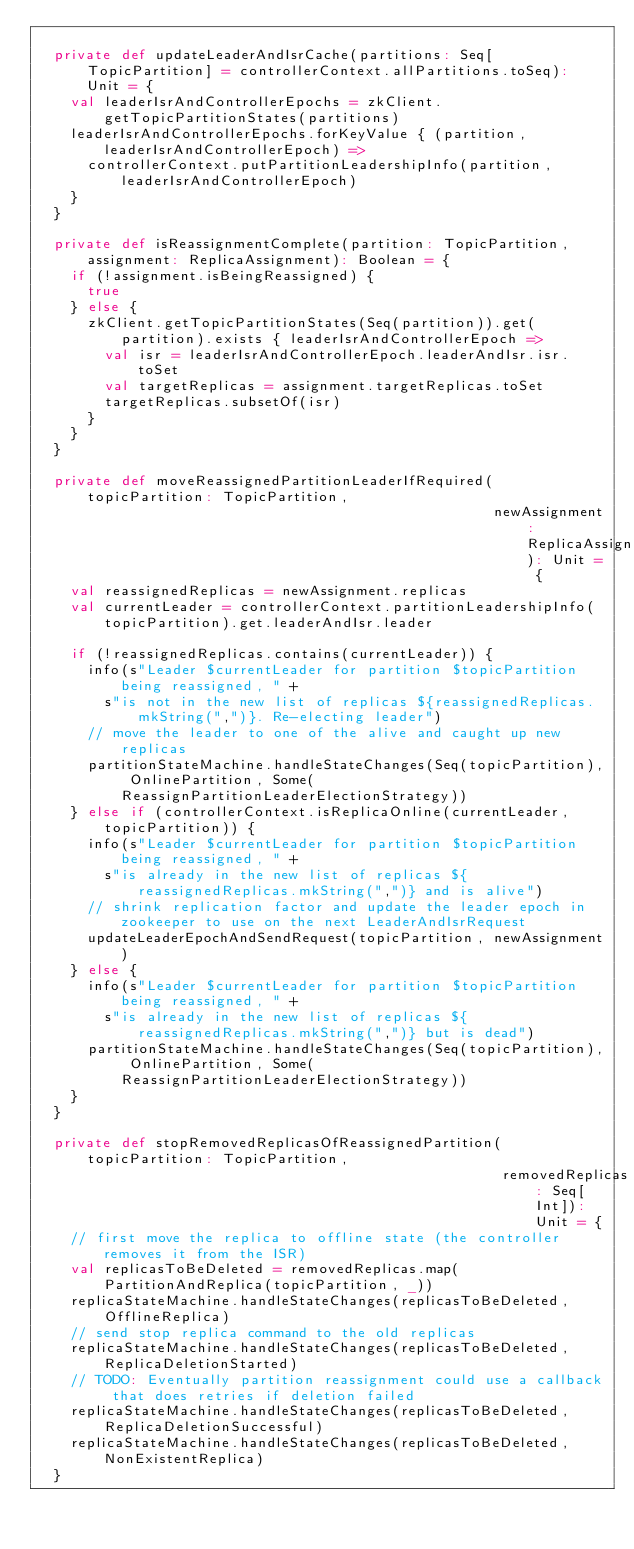Convert code to text. <code><loc_0><loc_0><loc_500><loc_500><_Scala_>
  private def updateLeaderAndIsrCache(partitions: Seq[TopicPartition] = controllerContext.allPartitions.toSeq): Unit = {
    val leaderIsrAndControllerEpochs = zkClient.getTopicPartitionStates(partitions)
    leaderIsrAndControllerEpochs.forKeyValue { (partition, leaderIsrAndControllerEpoch) =>
      controllerContext.putPartitionLeadershipInfo(partition, leaderIsrAndControllerEpoch)
    }
  }

  private def isReassignmentComplete(partition: TopicPartition, assignment: ReplicaAssignment): Boolean = {
    if (!assignment.isBeingReassigned) {
      true
    } else {
      zkClient.getTopicPartitionStates(Seq(partition)).get(partition).exists { leaderIsrAndControllerEpoch =>
        val isr = leaderIsrAndControllerEpoch.leaderAndIsr.isr.toSet
        val targetReplicas = assignment.targetReplicas.toSet
        targetReplicas.subsetOf(isr)
      }
    }
  }

  private def moveReassignedPartitionLeaderIfRequired(topicPartition: TopicPartition,
                                                      newAssignment: ReplicaAssignment): Unit = {
    val reassignedReplicas = newAssignment.replicas
    val currentLeader = controllerContext.partitionLeadershipInfo(topicPartition).get.leaderAndIsr.leader

    if (!reassignedReplicas.contains(currentLeader)) {
      info(s"Leader $currentLeader for partition $topicPartition being reassigned, " +
        s"is not in the new list of replicas ${reassignedReplicas.mkString(",")}. Re-electing leader")
      // move the leader to one of the alive and caught up new replicas
      partitionStateMachine.handleStateChanges(Seq(topicPartition), OnlinePartition, Some(ReassignPartitionLeaderElectionStrategy))
    } else if (controllerContext.isReplicaOnline(currentLeader, topicPartition)) {
      info(s"Leader $currentLeader for partition $topicPartition being reassigned, " +
        s"is already in the new list of replicas ${reassignedReplicas.mkString(",")} and is alive")
      // shrink replication factor and update the leader epoch in zookeeper to use on the next LeaderAndIsrRequest
      updateLeaderEpochAndSendRequest(topicPartition, newAssignment)
    } else {
      info(s"Leader $currentLeader for partition $topicPartition being reassigned, " +
        s"is already in the new list of replicas ${reassignedReplicas.mkString(",")} but is dead")
      partitionStateMachine.handleStateChanges(Seq(topicPartition), OnlinePartition, Some(ReassignPartitionLeaderElectionStrategy))
    }
  }

  private def stopRemovedReplicasOfReassignedPartition(topicPartition: TopicPartition,
                                                       removedReplicas: Seq[Int]): Unit = {
    // first move the replica to offline state (the controller removes it from the ISR)
    val replicasToBeDeleted = removedReplicas.map(PartitionAndReplica(topicPartition, _))
    replicaStateMachine.handleStateChanges(replicasToBeDeleted, OfflineReplica)
    // send stop replica command to the old replicas
    replicaStateMachine.handleStateChanges(replicasToBeDeleted, ReplicaDeletionStarted)
    // TODO: Eventually partition reassignment could use a callback that does retries if deletion failed
    replicaStateMachine.handleStateChanges(replicasToBeDeleted, ReplicaDeletionSuccessful)
    replicaStateMachine.handleStateChanges(replicasToBeDeleted, NonExistentReplica)
  }
</code> 